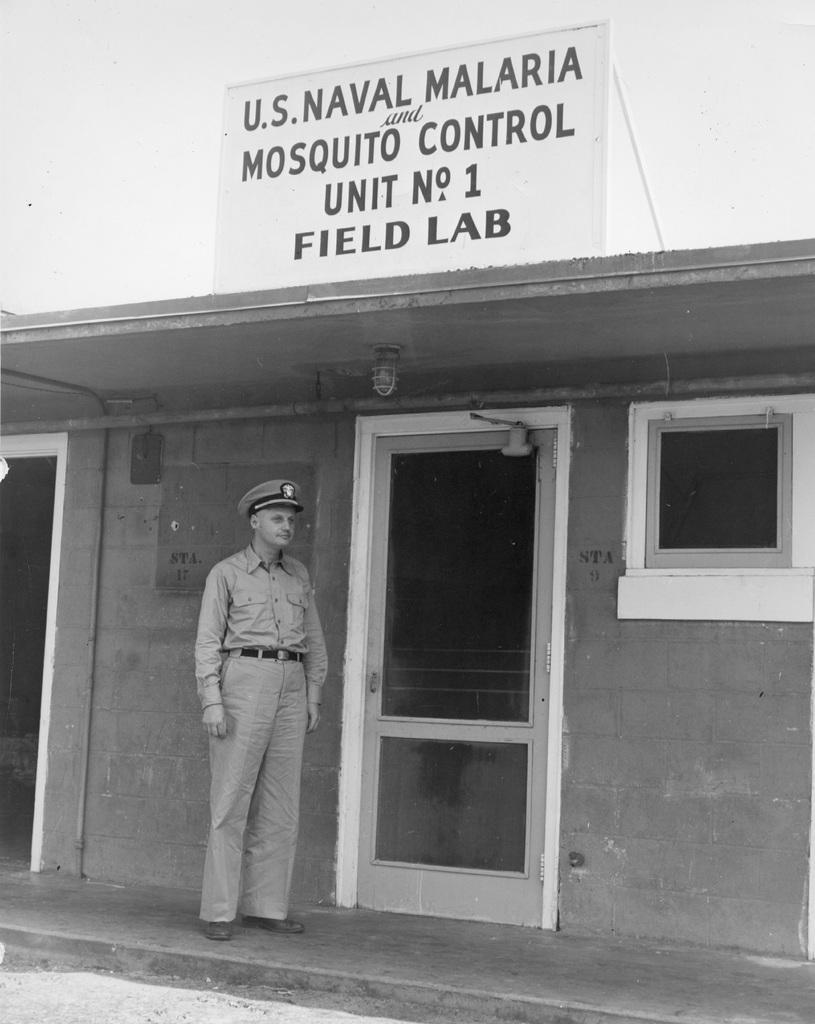How would you summarize this image in a sentence or two? It looks like a black and white picture. We can see a man is standing on the path and behind the man there is a wall with a door and a window. At the top there is a light and there is a board on the roof. 